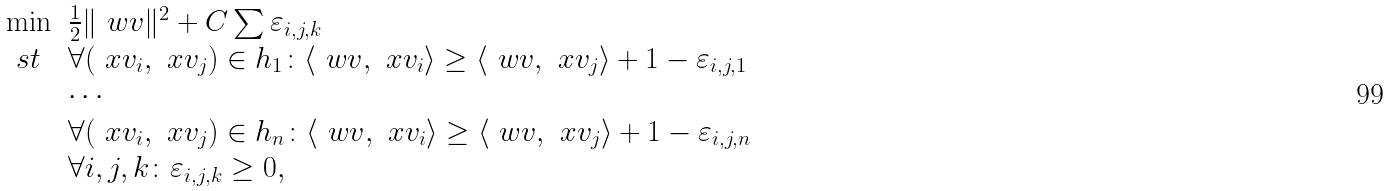Convert formula to latex. <formula><loc_0><loc_0><loc_500><loc_500>\begin{array} { l l } \min & \frac { 1 } { 2 } \| \ w v \| ^ { 2 } + C \sum \varepsilon _ { i , j , k } \\ \ s t & \forall ( \ x v _ { i } , \ x v _ { j } ) \in h _ { 1 } \colon \langle \ w v , \ x v _ { i } \rangle \geq \langle \ w v , \ x v _ { j } \rangle + 1 - \varepsilon _ { i , j , 1 } \\ & \cdots \\ & \forall ( \ x v _ { i } , \ x v _ { j } ) \in h _ { n } \colon \langle \ w v , \ x v _ { i } \rangle \geq \langle \ w v , \ x v _ { j } \rangle + 1 - \varepsilon _ { i , j , n } \\ & \forall i , j , k \colon \varepsilon _ { i , j , k } \geq 0 , \end{array}</formula> 